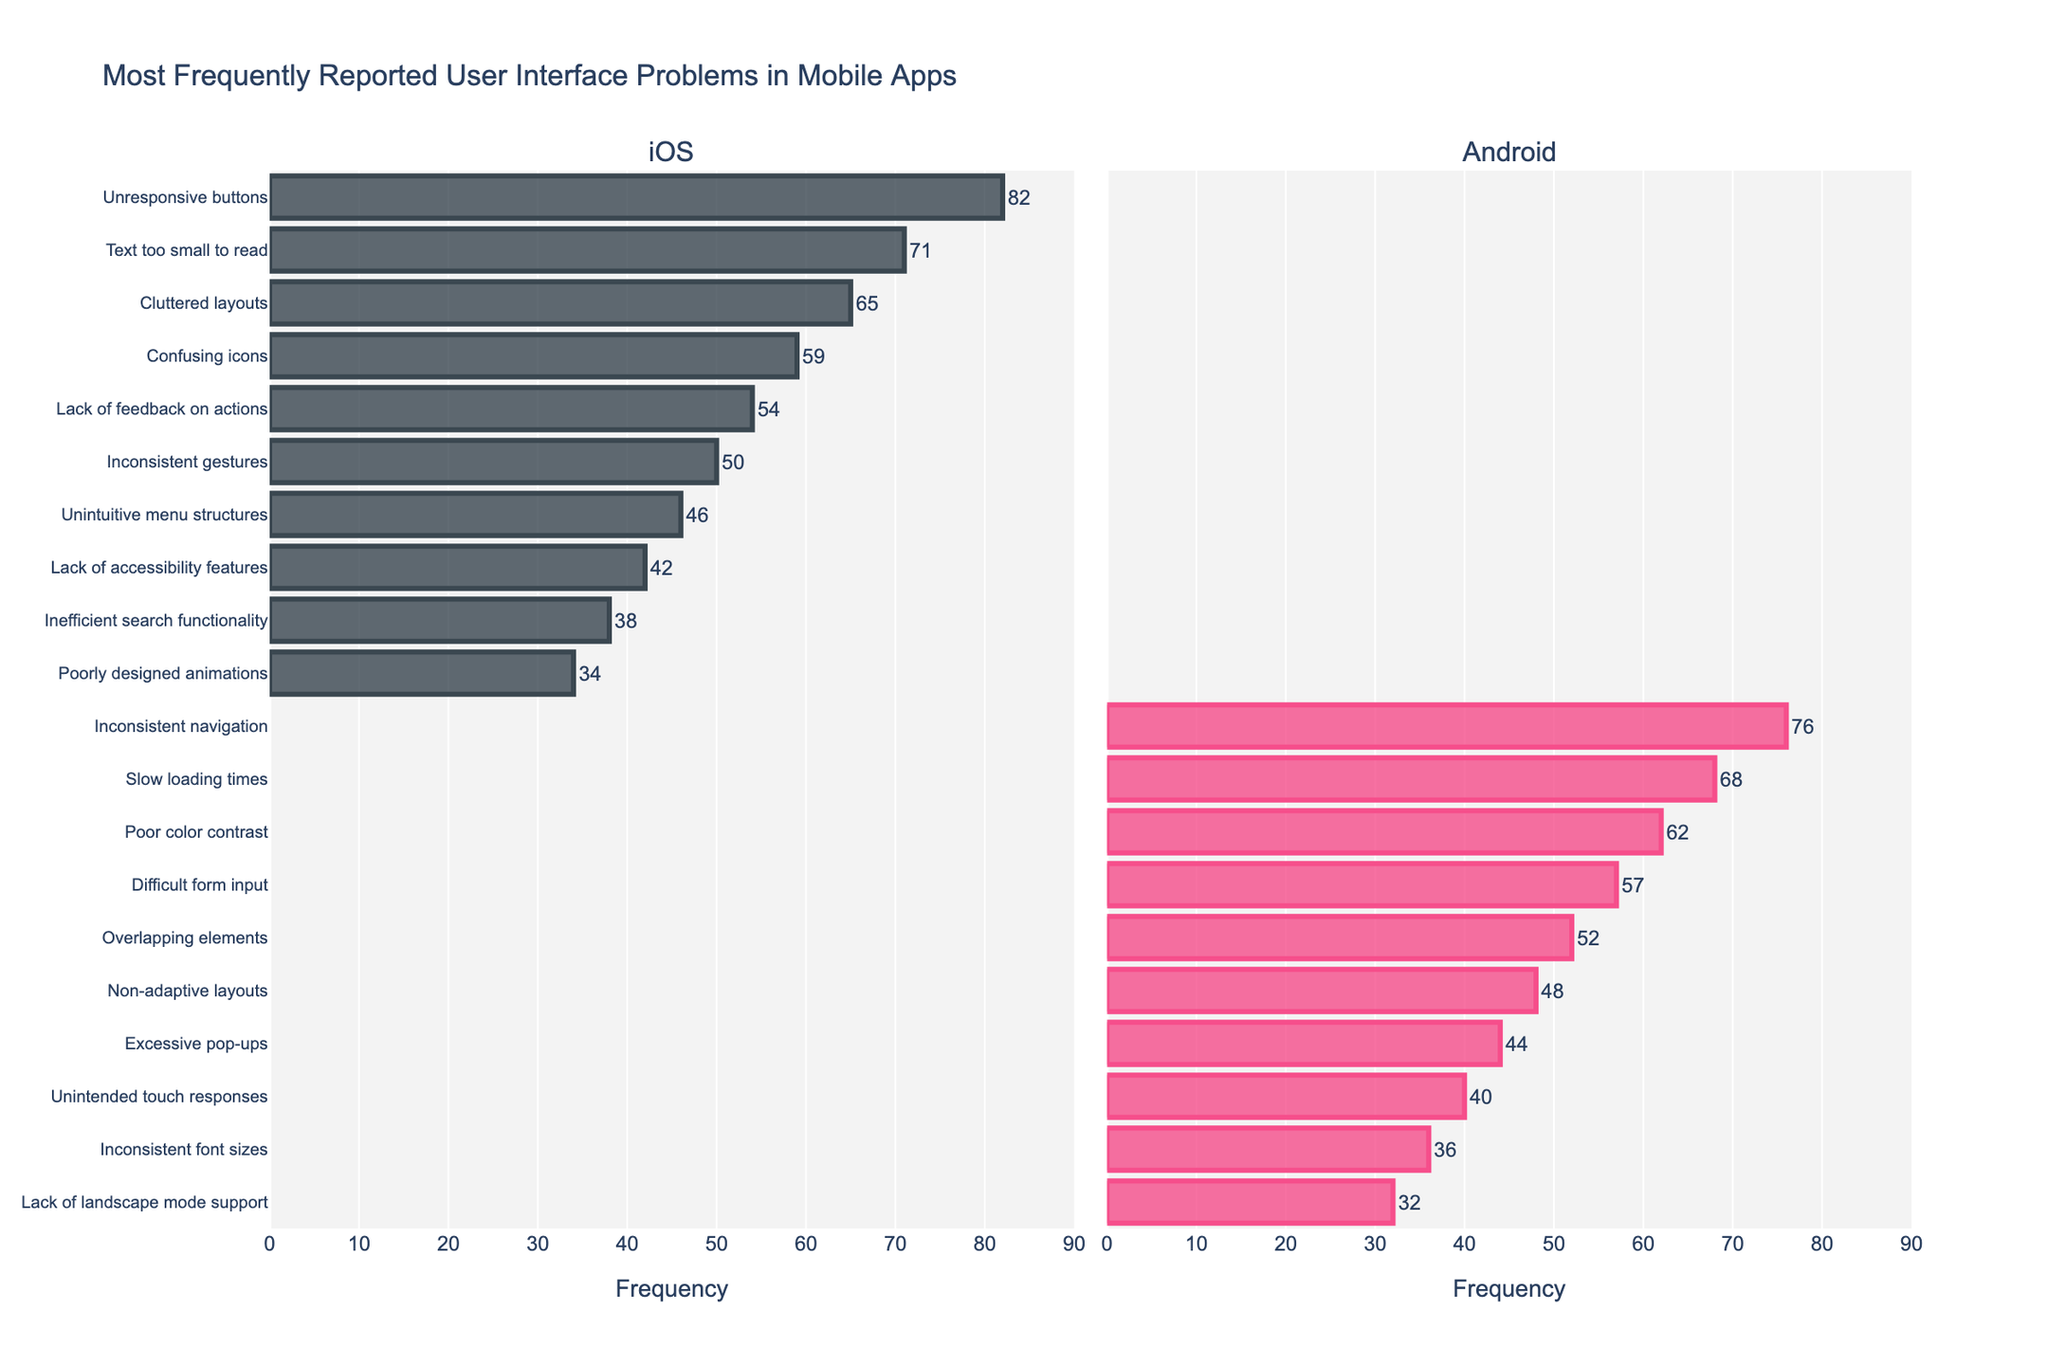Which platform has the highest frequency of reported problems? The highest frequency of reported problems can be determined by comparing the highest bars on each platform's bar chart. The highest bar in the iOS section is "Unresponsive buttons" at 82, while in the Android section, it is "Inconsistent navigation" at 76. Therefore, iOS has the highest frequency of reported problems.
Answer: iOS What is the combined frequency of "Unresponsive buttons" on iOS and "Inconsistent navigation" on Android? To find the combined frequency, sum the frequency of "Unresponsive buttons" on iOS (82) and "Inconsistent navigation" on Android (76). Thus, 82 + 76 = 158.
Answer: 158 Which problem is reported more frequently on Android compared to its counterpart on iOS: "Inconsistent navigation" or "Unresponsive buttons"? "Inconsistent navigation" on Android has a frequency of 76, and "Unresponsive buttons" on iOS has a frequency of 82. To find which problem is reported more frequently on Android, we compare these values. Since 76 is less than 82, neither of the mentioned problems is more frequently reported on Android than its iOS counterpart.
Answer: Neither Which problem has the closest frequency values between iOS and Android? By comparing the frequencies of all problems between iOS and Android, we find that "Unintended touch responses" on Android (40) and "Inefficient search functionality" on iOS (38) have the closest frequency values, with a difference of 2.
Answer: Unintended touch responses and Inefficient search functionality What is the difference in frequency between "Text too small to read" on iOS and "Slow loading times" on Android? To find the difference, subtract the frequency of "Slow loading times" on Android (68) from "Text too small to read" on iOS (71). Thus, 71 - 68 = 3.
Answer: 3 Which reported problem on Android has the lowest frequency, and what is its value? By examining the bar chart for Android, "Lack of landscape mode support" has the lowest frequency, which is 32.
Answer: Lack of landscape mode support, 32 What is the total number of problems reported on both platforms that have a frequency greater than 50? Count the bars on both platforms that have frequencies greater than 50. For iOS, there are 5 such problems: "Unresponsive buttons", "Text too small to read", "Cluttered layouts", "Confusing icons", and "Lack of feedback on actions". For Android, there are 4 such problems: "Inconsistent navigation", "Slow loading times", "Poor color contrast", and "Difficult form input". Thus, the total number is 5 + 4 = 9.
Answer: 9 Which iOS problem has exactly half the frequency of the "Unresponsive buttons" problem on iOS? The frequency of "Unresponsive buttons" on iOS is 82. Half of this value is 82 / 2 = 41. The "Lack of accessibility features" problem on iOS has a frequency closest to 41, which is 42.
Answer: Lack of accessibility features Which platform shows a more diverse set of problems with higher frequencies overall? By comparing the spread and the heights of the bars across both platforms, iOS has a higher number of problems with frequencies above 50, indicating a more diverse set of higher-frequency problems compared to Android.
Answer: iOS 